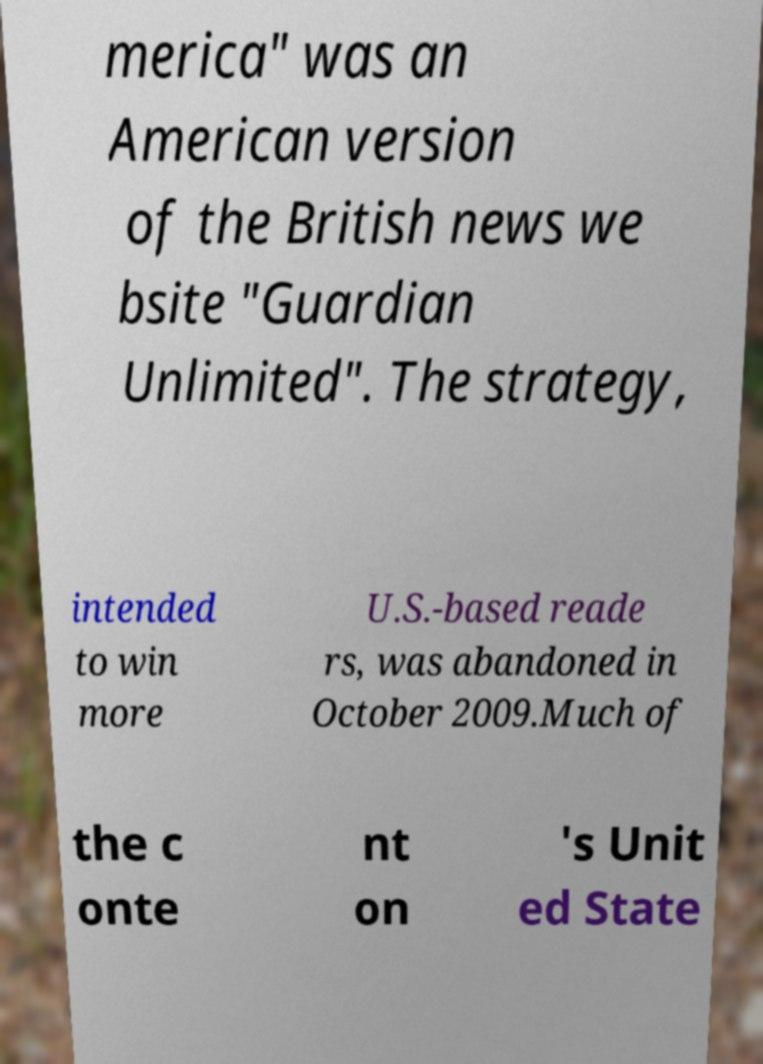What messages or text are displayed in this image? I need them in a readable, typed format. merica" was an American version of the British news we bsite "Guardian Unlimited". The strategy, intended to win more U.S.-based reade rs, was abandoned in October 2009.Much of the c onte nt on 's Unit ed State 